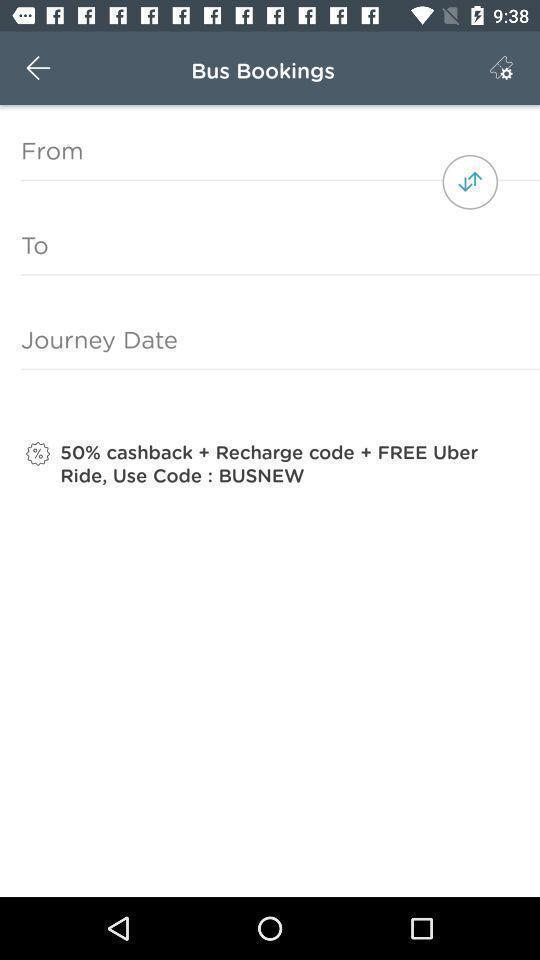Describe this image in words. Page to enter details to book tickets. 